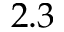<formula> <loc_0><loc_0><loc_500><loc_500>2 . 3</formula> 